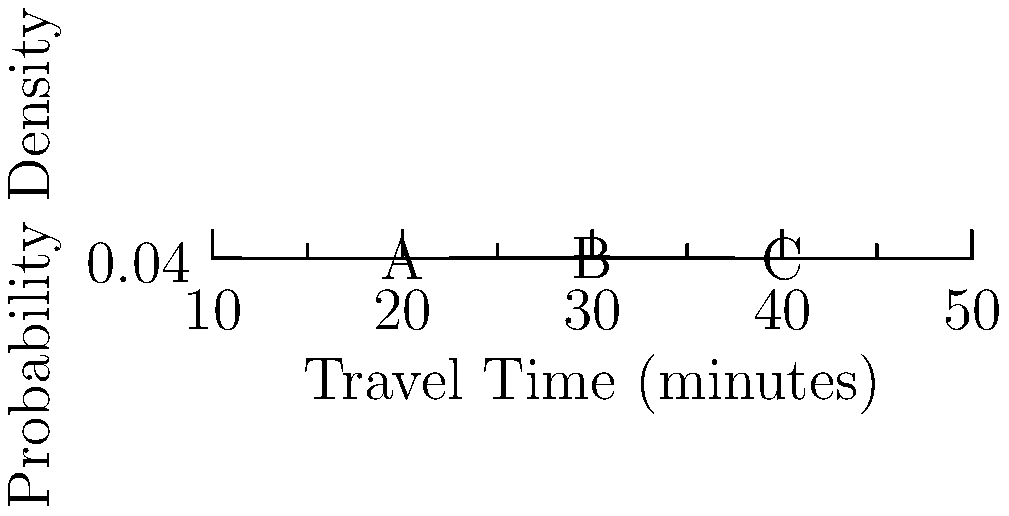As a hospital nurse relying on accurate travel time estimates, you're analyzing the probability distribution of your commute times. The graph shows a normal distribution of travel times. If your shift starts at 7:00 AM and you aim to arrive with 95% certainty, how many minutes before 7:00 AM should you leave home, assuming the mean travel time is 30 minutes? To solve this problem, we'll follow these steps:

1. Recognize that the graph represents a normal distribution with a mean of 30 minutes.

2. Recall that for a normal distribution:
   - 68% of data falls within 1 standard deviation (SD) of the mean
   - 95% of data falls within 2 SD of the mean
   - 99.7% of data falls within 3 SD of the mean

3. We need the 95% certainty range, which corresponds to 2 SD.

4. From the graph, we can estimate the standard deviation:
   The curve extends about 10 minutes on each side of the mean, so 1 SD ≈ 5 minutes.

5. Calculate the upper bound of the 95% certainty range:
   Upper bound = Mean + (2 × SD)
                = 30 + (2 × 5)
                = 40 minutes

6. To ensure 95% certainty of arriving on time, you should leave home 40 minutes before your shift starts.

Therefore, you should leave 40 minutes before 7:00 AM, which is at 6:20 AM.
Answer: 40 minutes before 7:00 AM (at 6:20 AM) 